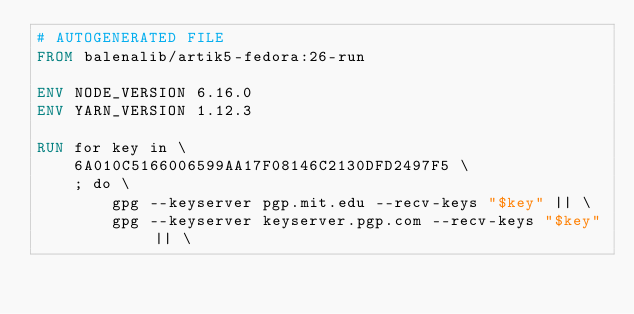<code> <loc_0><loc_0><loc_500><loc_500><_Dockerfile_># AUTOGENERATED FILE
FROM balenalib/artik5-fedora:26-run

ENV NODE_VERSION 6.16.0
ENV YARN_VERSION 1.12.3

RUN for key in \
	6A010C5166006599AA17F08146C2130DFD2497F5 \
	; do \
		gpg --keyserver pgp.mit.edu --recv-keys "$key" || \
		gpg --keyserver keyserver.pgp.com --recv-keys "$key" || \</code> 